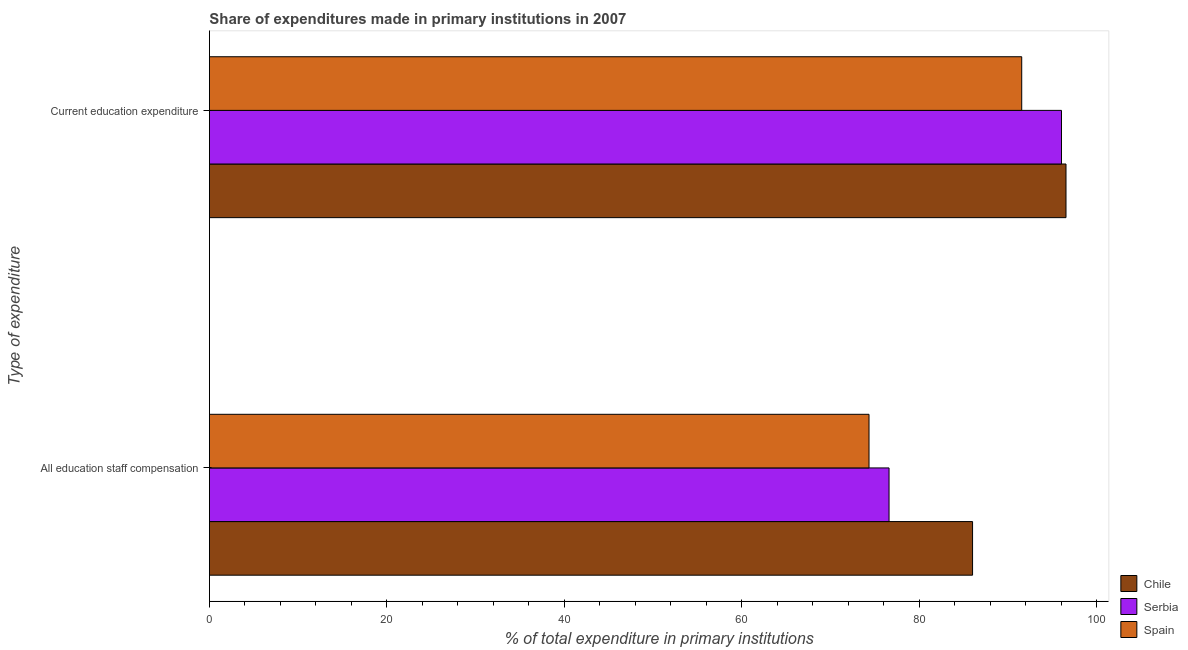How many groups of bars are there?
Provide a short and direct response. 2. What is the label of the 2nd group of bars from the top?
Make the answer very short. All education staff compensation. What is the expenditure in education in Serbia?
Keep it short and to the point. 96.05. Across all countries, what is the maximum expenditure in staff compensation?
Give a very brief answer. 86.03. Across all countries, what is the minimum expenditure in staff compensation?
Ensure brevity in your answer.  74.35. What is the total expenditure in education in the graph?
Your answer should be very brief. 284.18. What is the difference between the expenditure in education in Spain and that in Chile?
Offer a very short reply. -4.99. What is the difference between the expenditure in staff compensation in Spain and the expenditure in education in Chile?
Ensure brevity in your answer.  -22.21. What is the average expenditure in staff compensation per country?
Your answer should be compact. 79. What is the difference between the expenditure in education and expenditure in staff compensation in Serbia?
Provide a short and direct response. 19.44. In how many countries, is the expenditure in education greater than 24 %?
Keep it short and to the point. 3. What is the ratio of the expenditure in education in Chile to that in Spain?
Your answer should be very brief. 1.05. Is the expenditure in staff compensation in Chile less than that in Spain?
Provide a short and direct response. No. What does the 3rd bar from the top in Current education expenditure represents?
Keep it short and to the point. Chile. What does the 3rd bar from the bottom in All education staff compensation represents?
Offer a terse response. Spain. How many countries are there in the graph?
Your response must be concise. 3. How are the legend labels stacked?
Your answer should be very brief. Vertical. What is the title of the graph?
Your answer should be compact. Share of expenditures made in primary institutions in 2007. Does "Sao Tome and Principe" appear as one of the legend labels in the graph?
Provide a succinct answer. No. What is the label or title of the X-axis?
Your answer should be compact. % of total expenditure in primary institutions. What is the label or title of the Y-axis?
Offer a terse response. Type of expenditure. What is the % of total expenditure in primary institutions in Chile in All education staff compensation?
Offer a terse response. 86.03. What is the % of total expenditure in primary institutions of Serbia in All education staff compensation?
Ensure brevity in your answer.  76.61. What is the % of total expenditure in primary institutions in Spain in All education staff compensation?
Keep it short and to the point. 74.35. What is the % of total expenditure in primary institutions of Chile in Current education expenditure?
Provide a short and direct response. 96.56. What is the % of total expenditure in primary institutions of Serbia in Current education expenditure?
Provide a short and direct response. 96.05. What is the % of total expenditure in primary institutions in Spain in Current education expenditure?
Your answer should be very brief. 91.57. Across all Type of expenditure, what is the maximum % of total expenditure in primary institutions of Chile?
Keep it short and to the point. 96.56. Across all Type of expenditure, what is the maximum % of total expenditure in primary institutions in Serbia?
Offer a very short reply. 96.05. Across all Type of expenditure, what is the maximum % of total expenditure in primary institutions in Spain?
Provide a short and direct response. 91.57. Across all Type of expenditure, what is the minimum % of total expenditure in primary institutions in Chile?
Provide a short and direct response. 86.03. Across all Type of expenditure, what is the minimum % of total expenditure in primary institutions of Serbia?
Offer a terse response. 76.61. Across all Type of expenditure, what is the minimum % of total expenditure in primary institutions in Spain?
Offer a terse response. 74.35. What is the total % of total expenditure in primary institutions of Chile in the graph?
Your answer should be compact. 182.59. What is the total % of total expenditure in primary institutions of Serbia in the graph?
Offer a very short reply. 172.66. What is the total % of total expenditure in primary institutions of Spain in the graph?
Give a very brief answer. 165.92. What is the difference between the % of total expenditure in primary institutions in Chile in All education staff compensation and that in Current education expenditure?
Offer a very short reply. -10.53. What is the difference between the % of total expenditure in primary institutions in Serbia in All education staff compensation and that in Current education expenditure?
Ensure brevity in your answer.  -19.44. What is the difference between the % of total expenditure in primary institutions of Spain in All education staff compensation and that in Current education expenditure?
Provide a short and direct response. -17.22. What is the difference between the % of total expenditure in primary institutions in Chile in All education staff compensation and the % of total expenditure in primary institutions in Serbia in Current education expenditure?
Offer a very short reply. -10.02. What is the difference between the % of total expenditure in primary institutions in Chile in All education staff compensation and the % of total expenditure in primary institutions in Spain in Current education expenditure?
Offer a terse response. -5.54. What is the difference between the % of total expenditure in primary institutions in Serbia in All education staff compensation and the % of total expenditure in primary institutions in Spain in Current education expenditure?
Keep it short and to the point. -14.96. What is the average % of total expenditure in primary institutions in Chile per Type of expenditure?
Give a very brief answer. 91.29. What is the average % of total expenditure in primary institutions of Serbia per Type of expenditure?
Ensure brevity in your answer.  86.33. What is the average % of total expenditure in primary institutions in Spain per Type of expenditure?
Offer a very short reply. 82.96. What is the difference between the % of total expenditure in primary institutions in Chile and % of total expenditure in primary institutions in Serbia in All education staff compensation?
Provide a succinct answer. 9.42. What is the difference between the % of total expenditure in primary institutions of Chile and % of total expenditure in primary institutions of Spain in All education staff compensation?
Your answer should be very brief. 11.67. What is the difference between the % of total expenditure in primary institutions of Serbia and % of total expenditure in primary institutions of Spain in All education staff compensation?
Provide a succinct answer. 2.26. What is the difference between the % of total expenditure in primary institutions in Chile and % of total expenditure in primary institutions in Serbia in Current education expenditure?
Provide a succinct answer. 0.51. What is the difference between the % of total expenditure in primary institutions of Chile and % of total expenditure in primary institutions of Spain in Current education expenditure?
Keep it short and to the point. 4.99. What is the difference between the % of total expenditure in primary institutions in Serbia and % of total expenditure in primary institutions in Spain in Current education expenditure?
Your answer should be compact. 4.48. What is the ratio of the % of total expenditure in primary institutions in Chile in All education staff compensation to that in Current education expenditure?
Make the answer very short. 0.89. What is the ratio of the % of total expenditure in primary institutions of Serbia in All education staff compensation to that in Current education expenditure?
Provide a succinct answer. 0.8. What is the ratio of the % of total expenditure in primary institutions of Spain in All education staff compensation to that in Current education expenditure?
Keep it short and to the point. 0.81. What is the difference between the highest and the second highest % of total expenditure in primary institutions in Chile?
Provide a succinct answer. 10.53. What is the difference between the highest and the second highest % of total expenditure in primary institutions of Serbia?
Make the answer very short. 19.44. What is the difference between the highest and the second highest % of total expenditure in primary institutions of Spain?
Give a very brief answer. 17.22. What is the difference between the highest and the lowest % of total expenditure in primary institutions of Chile?
Your answer should be very brief. 10.53. What is the difference between the highest and the lowest % of total expenditure in primary institutions in Serbia?
Offer a very short reply. 19.44. What is the difference between the highest and the lowest % of total expenditure in primary institutions in Spain?
Provide a succinct answer. 17.22. 